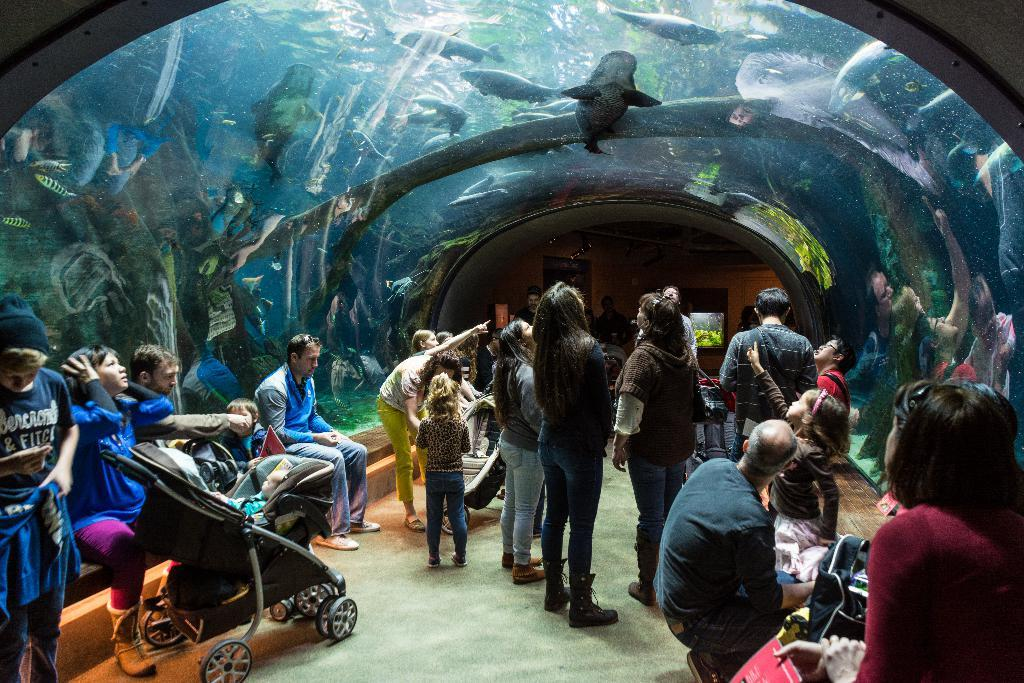Who is present in the image? There are people in the image. What are the people doing in the image? The people are watching something. What is the object of their attention? The object of their attention is an underwater aquarium. What can be seen inside the aquarium? There is a wide variety of fish in the aquarium. What type of match is being played in the image? There is no match being played in the image; the people are watching an underwater aquarium. Can you tell me the name of the brother of the person in the image? There is no information about any siblings or family members in the image. 